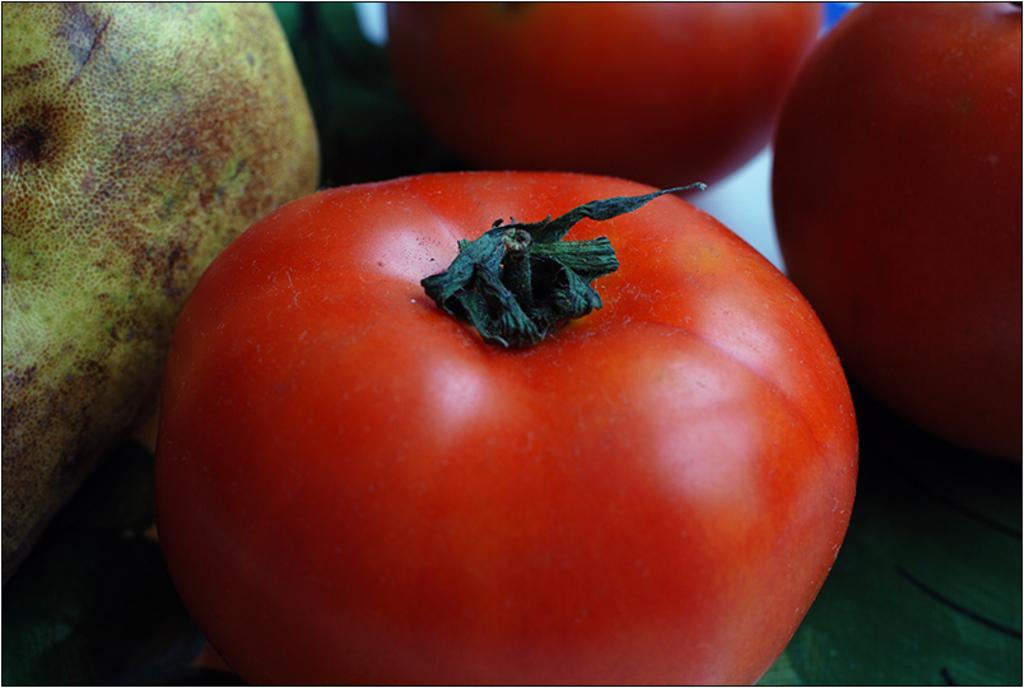Can you describe this image briefly? There is a red color tomato and there are two other tomatoes in front of it and there is an object in the left corner. 